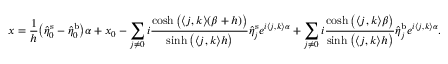Convert formula to latex. <formula><loc_0><loc_0><loc_500><loc_500>x = \frac { 1 } { h } \left ( \hat { \eta } _ { \boldsymbol 0 } ^ { s } - \hat { \eta } _ { \boldsymbol 0 } ^ { b } \right ) \alpha + x _ { 0 } - \sum _ { \boldsymbol j \neq \boldsymbol 0 } i \frac { \cosh \left ( \langle \boldsymbol j , \boldsymbol k \rangle ( \beta + h ) \right ) } { \sinh \left ( \langle \boldsymbol j , \boldsymbol k \rangle h \right ) } \hat { \eta } _ { \boldsymbol j } ^ { s } e ^ { i \langle \boldsymbol j , \boldsymbol k \rangle \alpha } + \sum _ { \boldsymbol j \neq \boldsymbol 0 } i \frac { \cosh \left ( \langle \boldsymbol j , \boldsymbol k \rangle \beta \right ) } { \sinh \left ( \langle \boldsymbol j , \boldsymbol k \rangle h \right ) } \hat { \eta } _ { \boldsymbol j } ^ { b } e ^ { i \langle \boldsymbol j , \boldsymbol k \rangle \alpha } .</formula> 